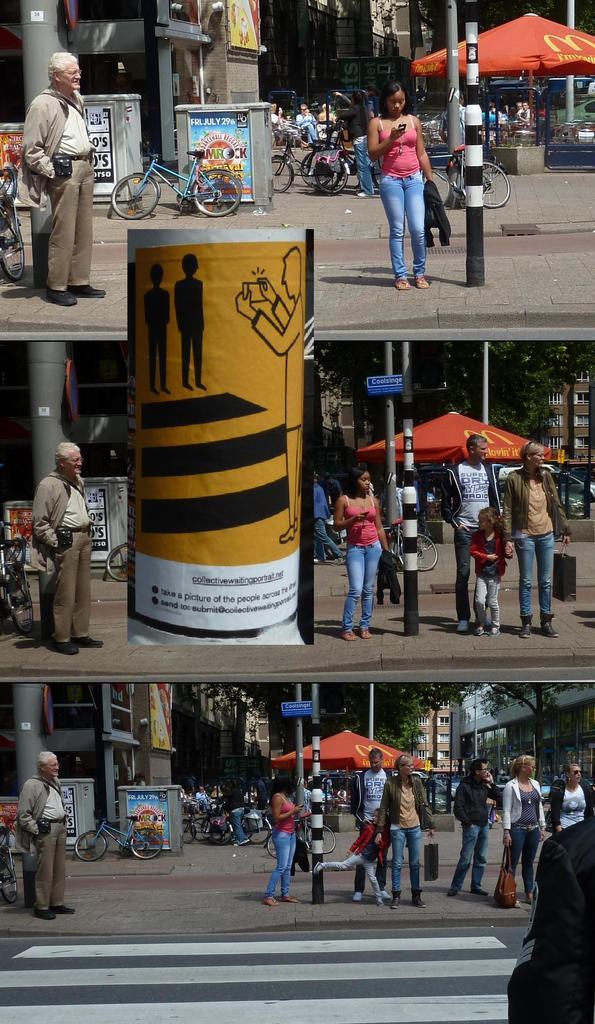Could they be waiting for public transport?
Provide a short and direct response. Answering does not require reading text in the image. 